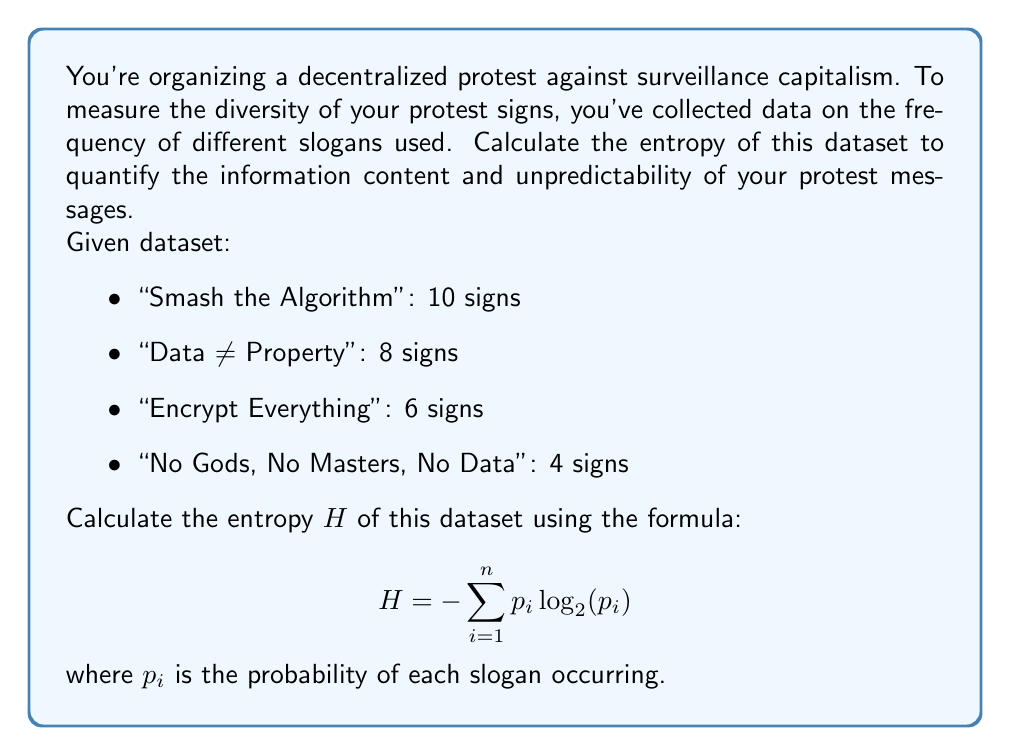Could you help me with this problem? To calculate the entropy of this dataset, we'll follow these steps:

1. Calculate the total number of signs:
   $10 + 8 + 6 + 4 = 28$ signs

2. Calculate the probability $p_i$ for each slogan:
   - $p_1 = 10/28 \approx 0.3571$
   - $p_2 = 8/28 \approx 0.2857$
   - $p_3 = 6/28 \approx 0.2143$
   - $p_4 = 4/28 \approx 0.1429$

3. Calculate $-p_i \log_2(p_i)$ for each slogan:
   - $-0.3571 \log_2(0.3571) \approx 0.5306$
   - $-0.2857 \log_2(0.2857) \approx 0.5200$
   - $-0.2143 \log_2(0.2143) \approx 0.4747$
   - $-0.1429 \log_2(0.1429) \approx 0.4016$

4. Sum up all the values to get the entropy:
   $H = 0.5306 + 0.5200 + 0.4747 + 0.4016 = 1.9269$

The entropy value of 1.9269 bits indicates the average amount of information contained in each protest sign. A higher entropy suggests more diverse and unpredictable slogans, which could make the protest messages more impactful and harder for authorities to anticipate or control.
Answer: $H \approx 1.9269$ bits 